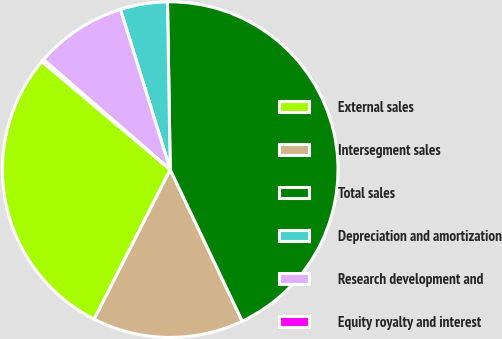<chart> <loc_0><loc_0><loc_500><loc_500><pie_chart><fcel>External sales<fcel>Intersegment sales<fcel>Total sales<fcel>Depreciation and amortization<fcel>Research development and<fcel>Equity royalty and interest<nl><fcel>28.65%<fcel>14.55%<fcel>43.2%<fcel>4.53%<fcel>8.83%<fcel>0.24%<nl></chart> 